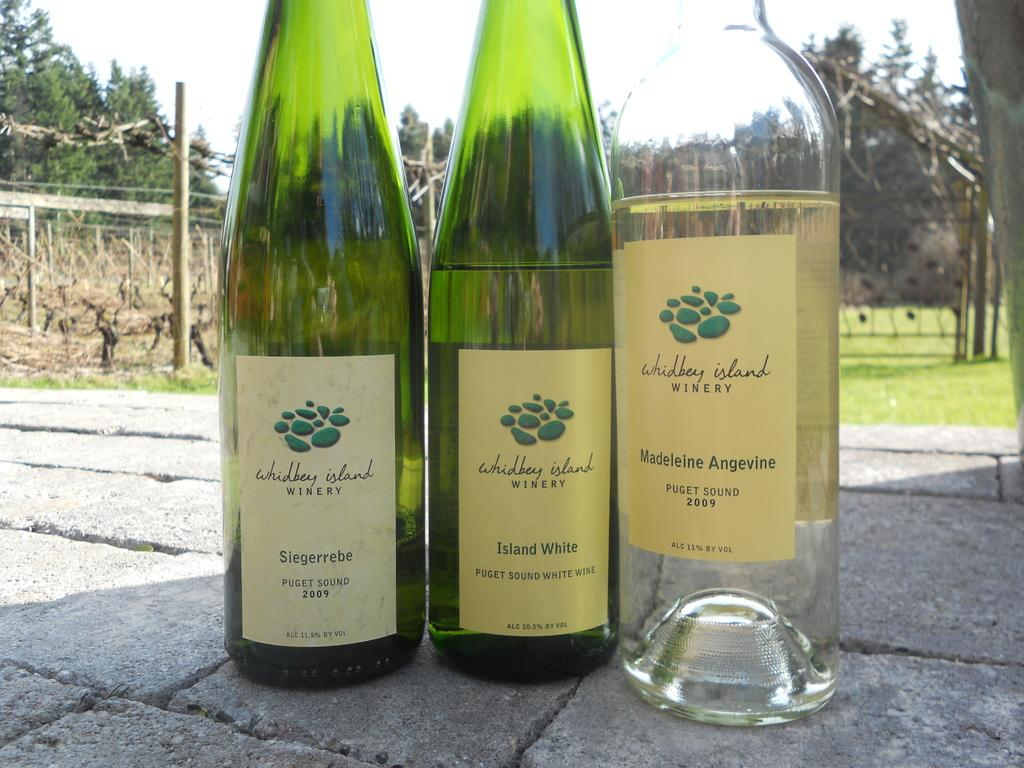<image>
Give a short and clear explanation of the subsequent image. the word winery on the front of a bottle 